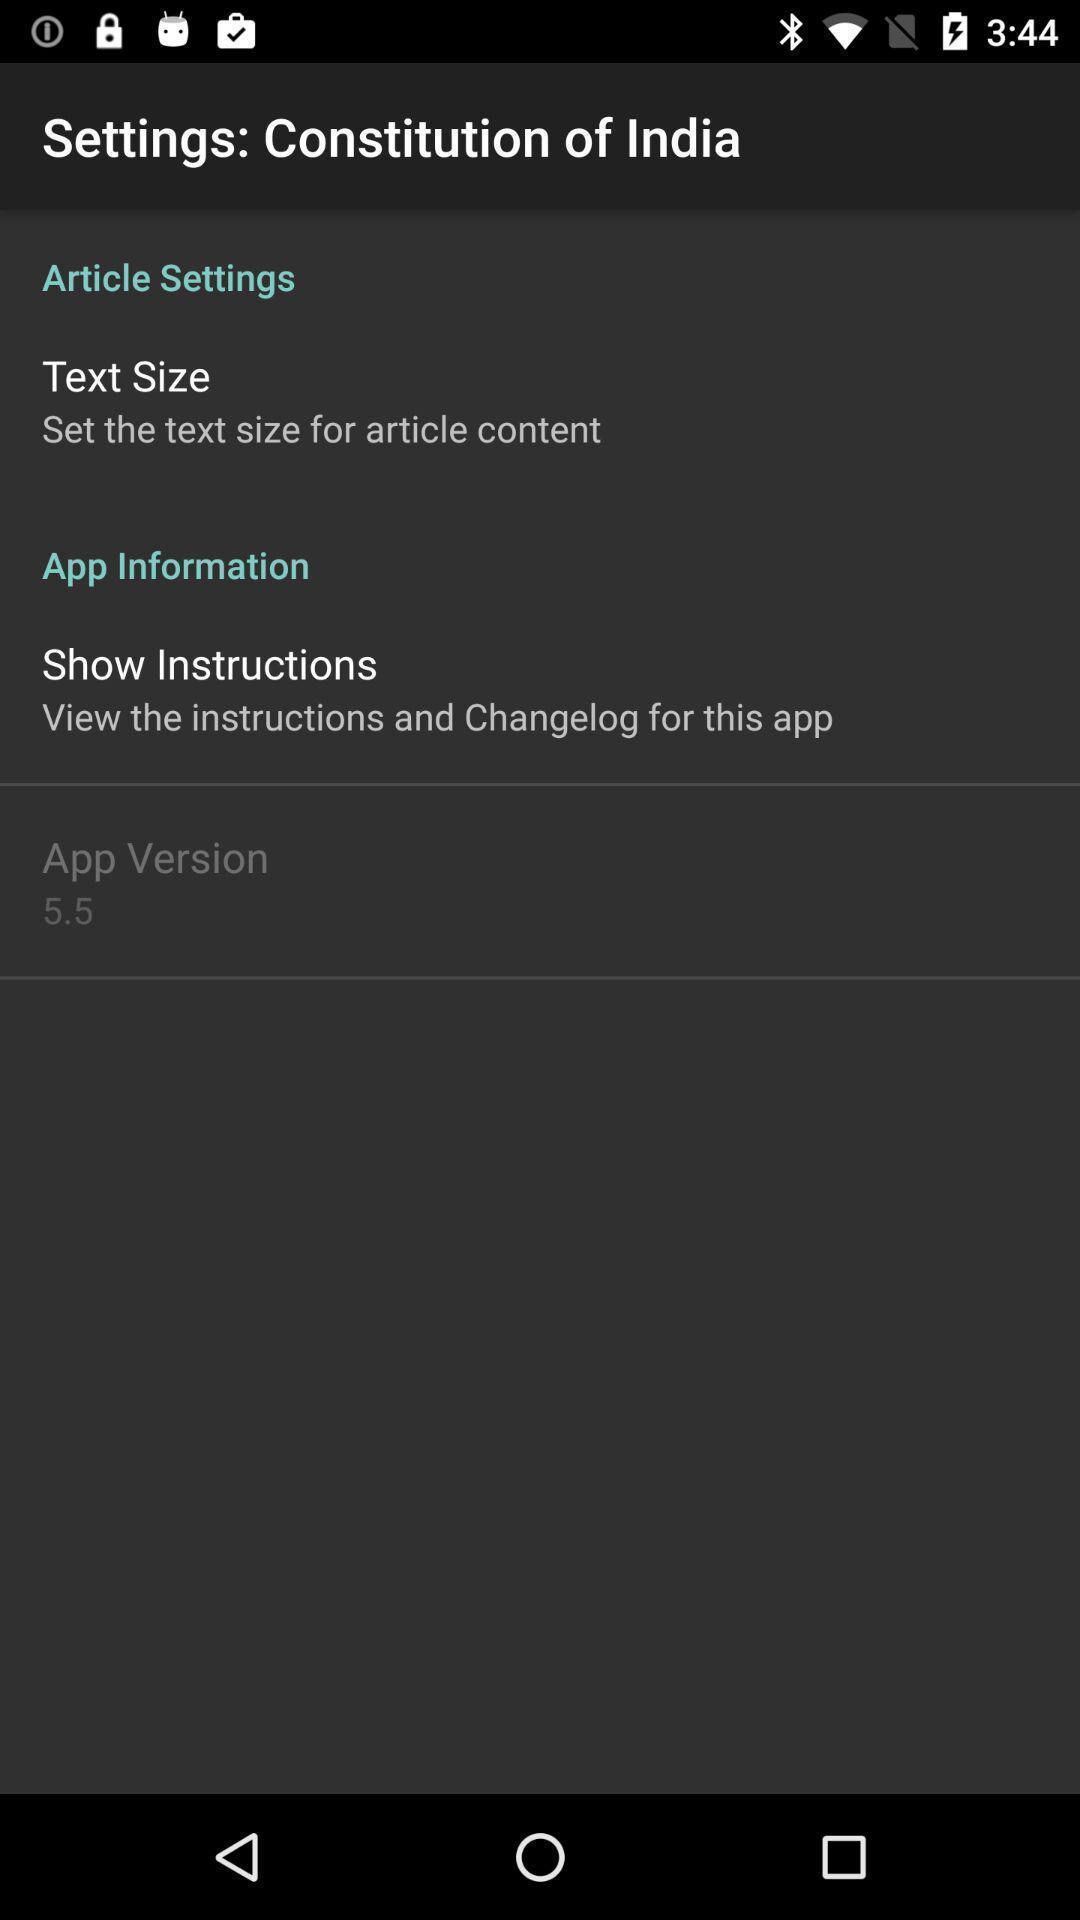Provide a detailed account of this screenshot. Settings page for the reading app. 